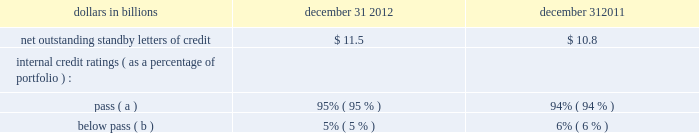Table 153 : net outstanding standby letters of credit dollars in billions december 31 december 31 .
( a ) indicates that expected risk of loss is currently low .
( b ) indicates a higher degree of risk of default .
If the customer fails to meet its financial or performance obligation to the third party under the terms of the contract or there is a need to support a remarketing program , then upon the request of the guaranteed party , subject to the terms of the letter of credit , we would be obligated to make payment to them .
The standby letters of credit and risk participations in standby letters of credit and bankers 2019 acceptances outstanding on december 31 , 2012 had terms ranging from less than 1 year to 7 years .
The aggregate maximum amount of future payments pnc could be required to make under outstanding standby letters of credit and risk participations in standby letters of credit and bankers 2019 acceptances was $ 14.7 billion at december 31 , 2012 , of which $ 7.5 billion support remarketing programs .
As of december 31 , 2012 , assets of $ 1.8 billion secured certain specifically identified standby letters of credit .
Recourse provisions from third parties of $ 3.2 billion were also available for this purpose as of december 31 , 2012 .
In addition , a portion of the remaining standby letters of credit and letter of credit risk participations issued on behalf of specific customers is also secured by collateral or guarantees that secure the customers 2019 other obligations to us .
The carrying amount of the liability for our obligations related to standby letters of credit and risk participations in standby letters of credit and bankers 2019 acceptances was $ 247 million at december 31 , 2012 .
Standby bond purchase agreements and other liquidity facilities we enter into standby bond purchase agreements to support municipal bond obligations .
At december 31 , 2012 , the aggregate of our commitments under these facilities was $ 587 million .
We also enter into certain other liquidity facilities to support individual pools of receivables acquired by commercial paper conduits .
At december 31 , 2012 , our total commitments under these facilities were $ 145 million .
Indemnifications we are a party to numerous acquisition or divestiture agreements under which we have purchased or sold , or agreed to purchase or sell , various types of assets .
These agreements can cover the purchase or sale of : 2022 entire businesses , 2022 loan portfolios , 2022 branch banks , 2022 partial interests in companies , or 2022 other types of assets .
These agreements generally include indemnification provisions under which we indemnify the third parties to these agreements against a variety of risks to the indemnified parties as a result of the transaction in question .
When pnc is the seller , the indemnification provisions will generally also provide the buyer with protection relating to the quality of the assets we are selling and the extent of any liabilities being assumed by the buyer .
Due to the nature of these indemnification provisions , we cannot quantify the total potential exposure to us resulting from them .
We provide indemnification in connection with securities offering transactions in which we are involved .
When we are the issuer of the securities , we provide indemnification to the underwriters or placement agents analogous to the indemnification provided to the purchasers of businesses from us , as described above .
When we are an underwriter or placement agent , we provide a limited indemnification to the issuer related to our actions in connection with the offering and , if there are other underwriters , indemnification to the other underwriters intended to result in an appropriate sharing of the risk of participating in the offering .
Due to the nature of these indemnification provisions , we cannot quantify the total potential exposure to us resulting from them .
In the ordinary course of business , we enter into certain types of agreements that include provisions for indemnifying third parties .
We also enter into certain types of agreements , including leases , assignments of leases , and subleases , in which we agree to indemnify third parties for acts by our agents , assignees and/or sublessees , and employees .
We also enter into contracts for the delivery of technology service in which we indemnify the other party against claims of patent and copyright infringement by third parties .
Due to the nature of these indemnification provisions , we cannot calculate our aggregate potential exposure under them .
In the ordinary course of business , we enter into contracts with third parties under which the third parties provide services on behalf of pnc .
In many of these contracts , we agree to indemnify the third party service provider under certain circumstances .
The terms of the indemnity vary from contract to contract and the amount of the indemnification liability , if any , cannot be determined .
We are a general or limited partner in certain asset management and investment limited partnerships , many of which contain indemnification provisions that would require us to make payments in excess of our remaining unfunded commitments .
While in certain of these partnerships the maximum liability to us is limited to the sum of our unfunded commitments and partnership distributions received by us , in the others the indemnification liability is unlimited .
As a result , we cannot determine our aggregate potential exposure for these indemnifications .
The pnc financial services group , inc .
2013 form 10-k 227 .
In billions , what was the change between 2011 and 2012 in net outstanding standby letters of credit? 
Computations: ((11.5 + 10.8) / 2)
Answer: 11.15. 